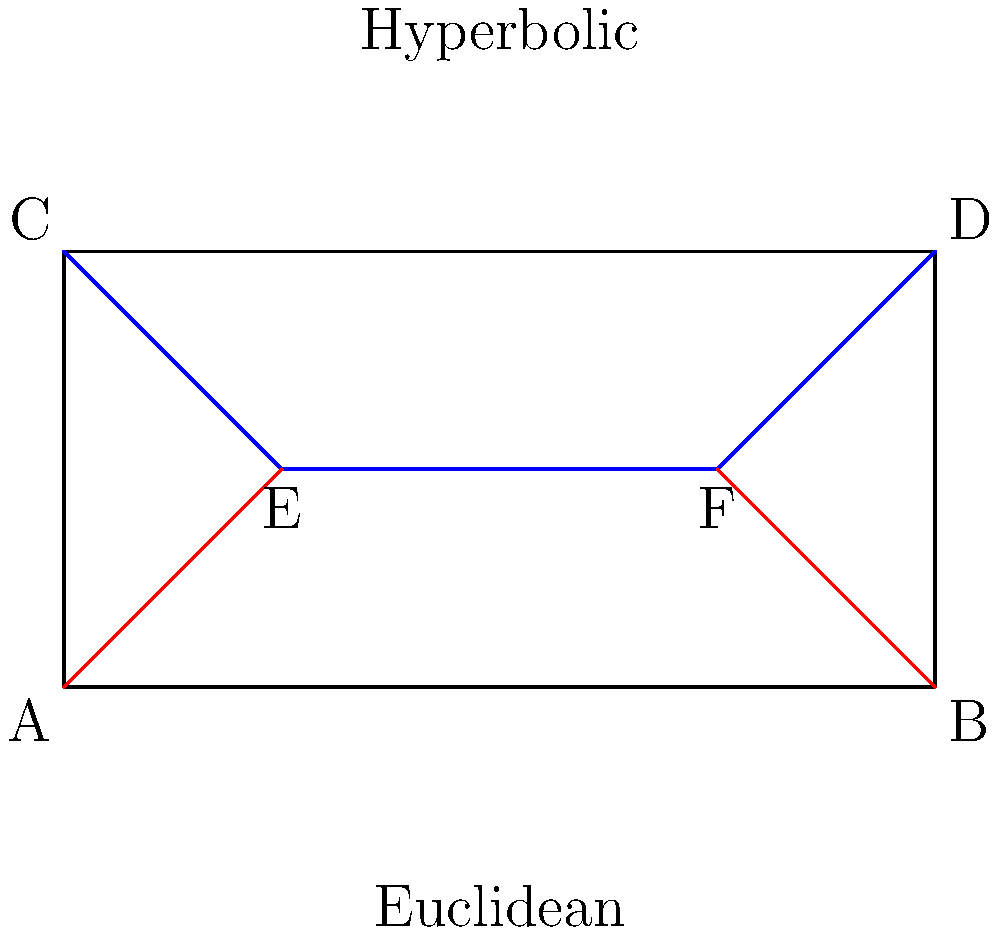In the context of 20th-century European conflicts, the concept of parallel lines in different geometries can be used as a metaphor for diverging ideologies. Consider the diagram showing parallel lines in Euclidean and hyperbolic geometries. If the red lines represent the trajectories of fascism and communism in the 1930s, which geometry would better illustrate their relationship, and why? To answer this question, let's analyze the properties of parallel lines in both geometries:

1. Euclidean geometry (bottom half of the diagram):
   - Parallel lines maintain a constant distance from each other.
   - They never intersect, no matter how far they are extended.

2. Hyperbolic geometry (top half of the diagram):
   - Parallel lines appear to diverge from each other.
   - The distance between them increases as they are extended.

Now, let's consider the historical context:

3. Fascism and communism in the 1930s:
   - Both ideologies started as alternatives to liberal democracy.
   - Initially, they shared some similarities (e.g., totalitarianism, opposition to capitalism).
   - However, as they developed, they became increasingly opposed to each other.

4. Divergence of ideologies:
   - Over time, fascism and communism became bitter enemies.
   - Their differences became more pronounced, leading to conflicts like the Spanish Civil War.

5. Hyperbolic geometry as a better representation:
   - The diverging nature of parallel lines in hyperbolic geometry better illustrates how fascism and communism grew apart.
   - It shows that while they may have started relatively close, they became increasingly distant and opposed over time.

Therefore, hyperbolic geometry provides a more accurate metaphor for the relationship between fascism and communism in the 1930s, as it captures their increasing divergence and opposition.
Answer: Hyperbolic geometry, as it illustrates the increasing divergence between fascism and communism over time. 